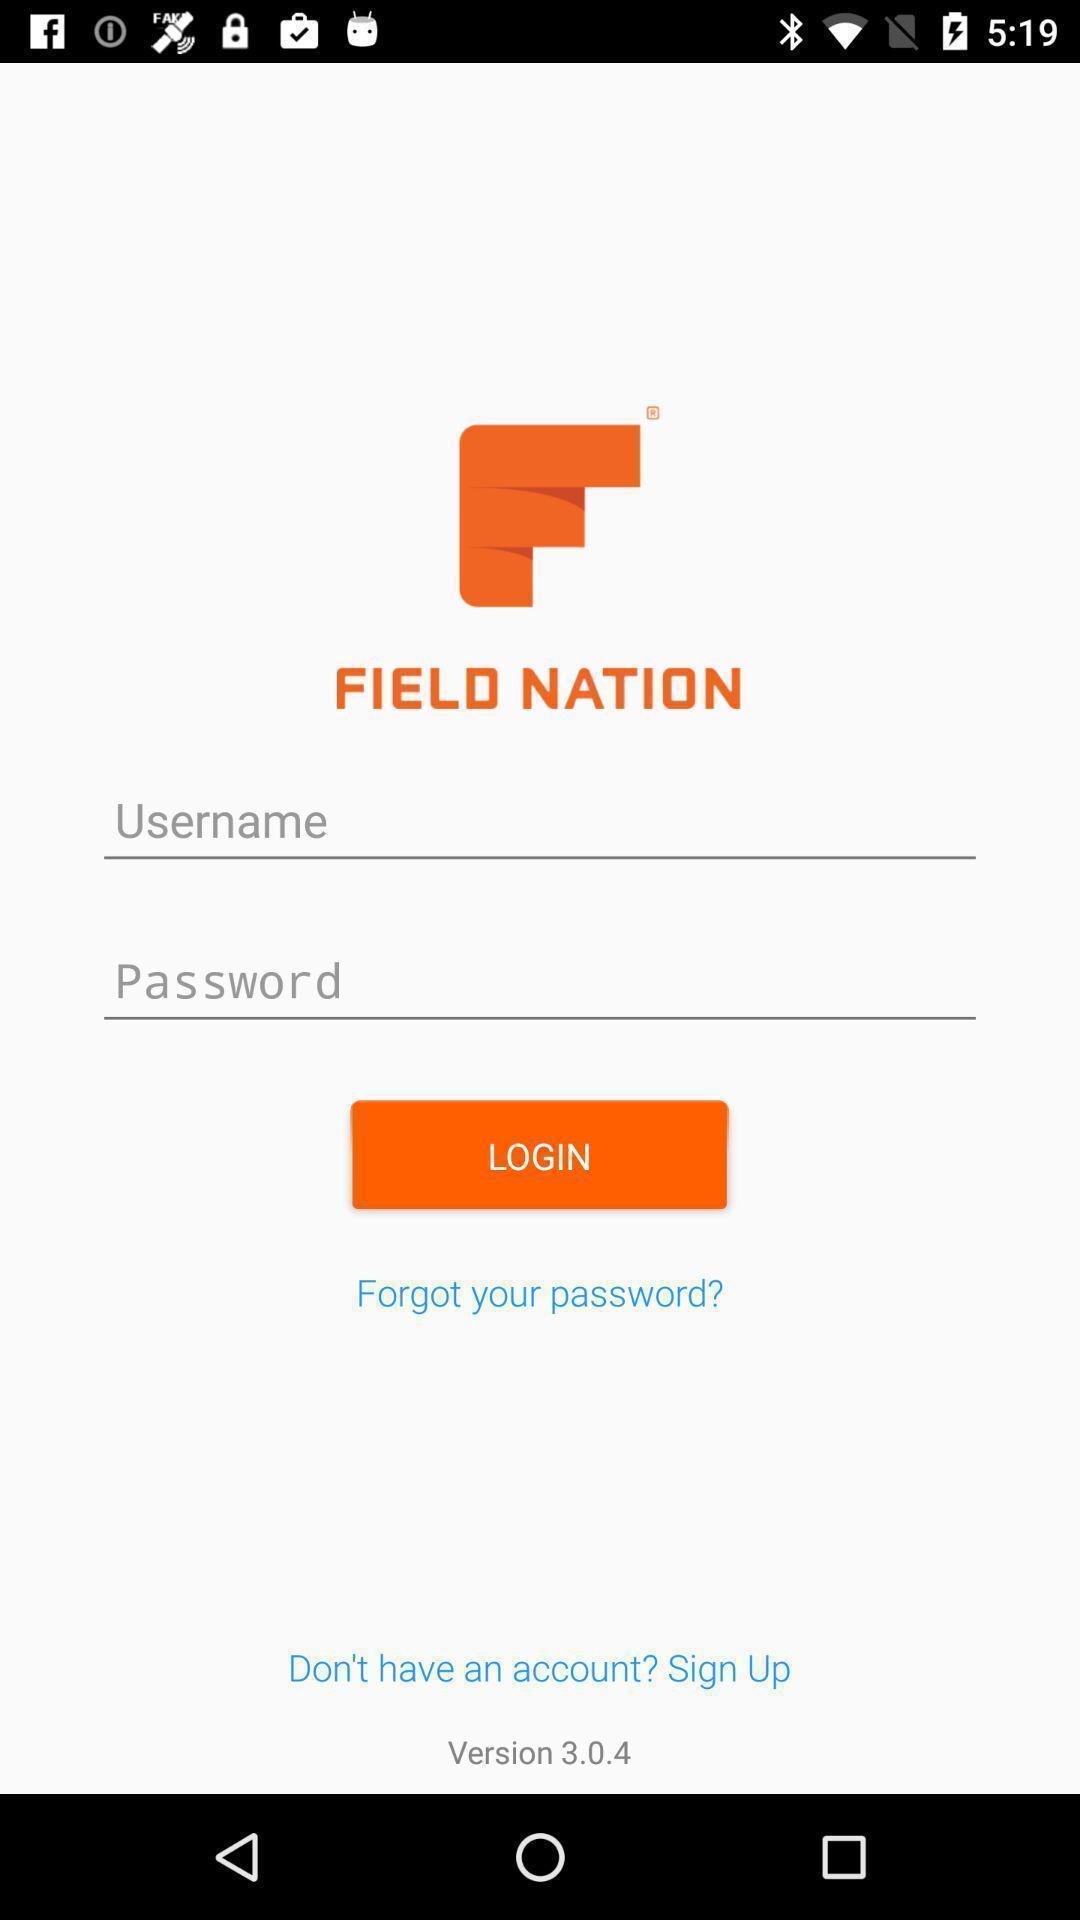Please provide a description for this image. Login page. 